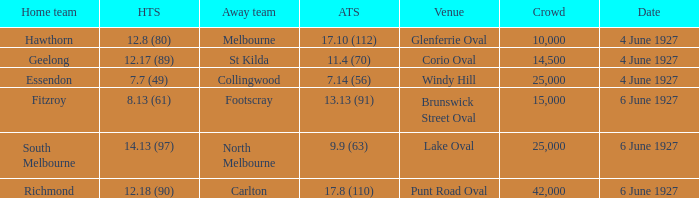Would you mind parsing the complete table? {'header': ['Home team', 'HTS', 'Away team', 'ATS', 'Venue', 'Crowd', 'Date'], 'rows': [['Hawthorn', '12.8 (80)', 'Melbourne', '17.10 (112)', 'Glenferrie Oval', '10,000', '4 June 1927'], ['Geelong', '12.17 (89)', 'St Kilda', '11.4 (70)', 'Corio Oval', '14,500', '4 June 1927'], ['Essendon', '7.7 (49)', 'Collingwood', '7.14 (56)', 'Windy Hill', '25,000', '4 June 1927'], ['Fitzroy', '8.13 (61)', 'Footscray', '13.13 (91)', 'Brunswick Street Oval', '15,000', '6 June 1927'], ['South Melbourne', '14.13 (97)', 'North Melbourne', '9.9 (63)', 'Lake Oval', '25,000', '6 June 1927'], ['Richmond', '12.18 (90)', 'Carlton', '17.8 (110)', 'Punt Road Oval', '42,000', '6 June 1927']]} Which team was at Corio Oval on 4 June 1927? St Kilda. 